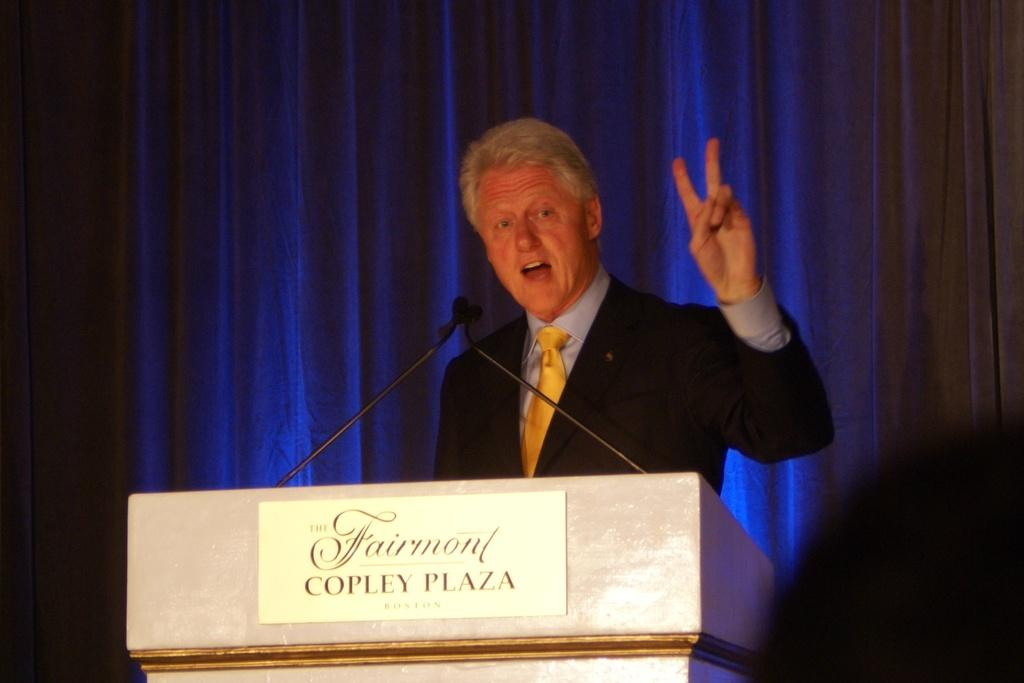<image>
Render a clear and concise summary of the photo. a man standing behind a podium that says 'fairmont copley plaza' on it 